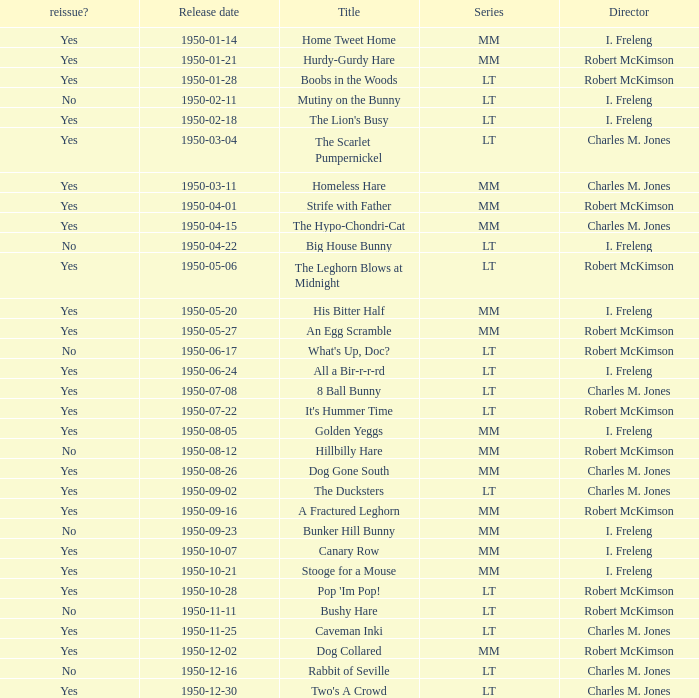Who directed Bunker Hill Bunny? I. Freleng. 